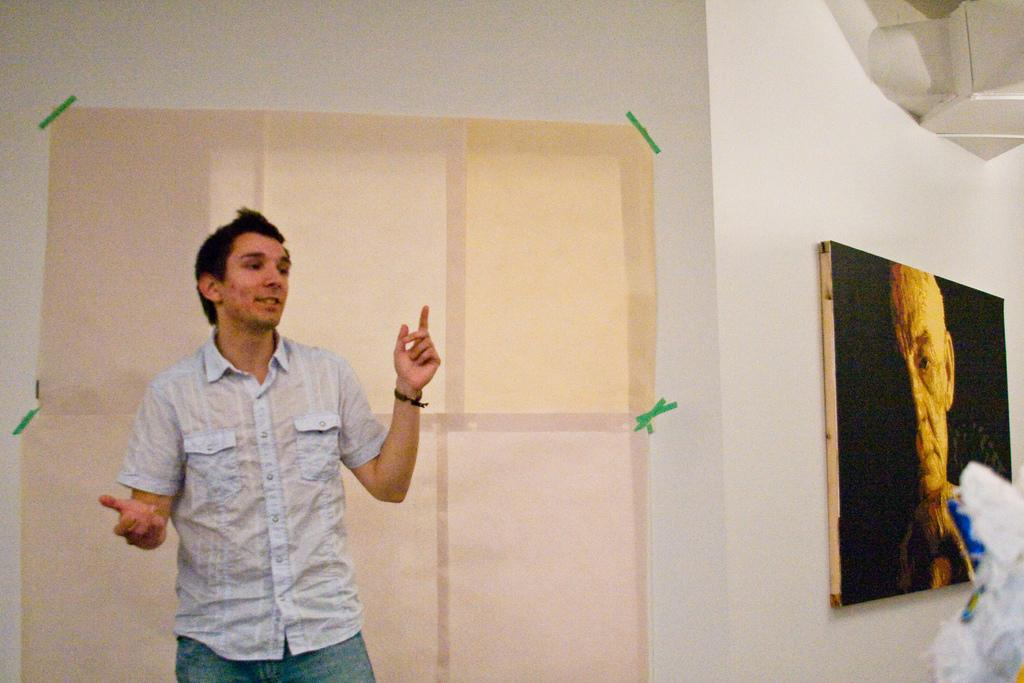Who is present in the image? There is a man in the image. What is the man doing in the image? The man is standing in the image. What is the man's facial expression in the image? The man is smiling in the image. What can be seen on the wall in the background of the image? There is a frame on the wall in the background of the image. What type of hat is the man wearing in the image? There is no hat present in the image; the man is not wearing a hat. 